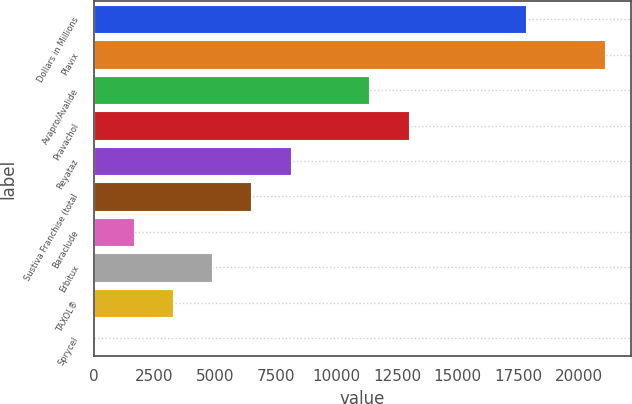Convert chart. <chart><loc_0><loc_0><loc_500><loc_500><bar_chart><fcel>Dollars in Millions<fcel>Plavix<fcel>Avapro/Avalide<fcel>Pravachol<fcel>Reyataz<fcel>Sustiva Franchise (total<fcel>Baraclude<fcel>Erbitux<fcel>TAXOL®<fcel>Sprycel<nl><fcel>17826.3<fcel>21062.9<fcel>11353.1<fcel>12971.4<fcel>8116.5<fcel>6498.2<fcel>1643.3<fcel>4879.9<fcel>3261.6<fcel>25<nl></chart> 